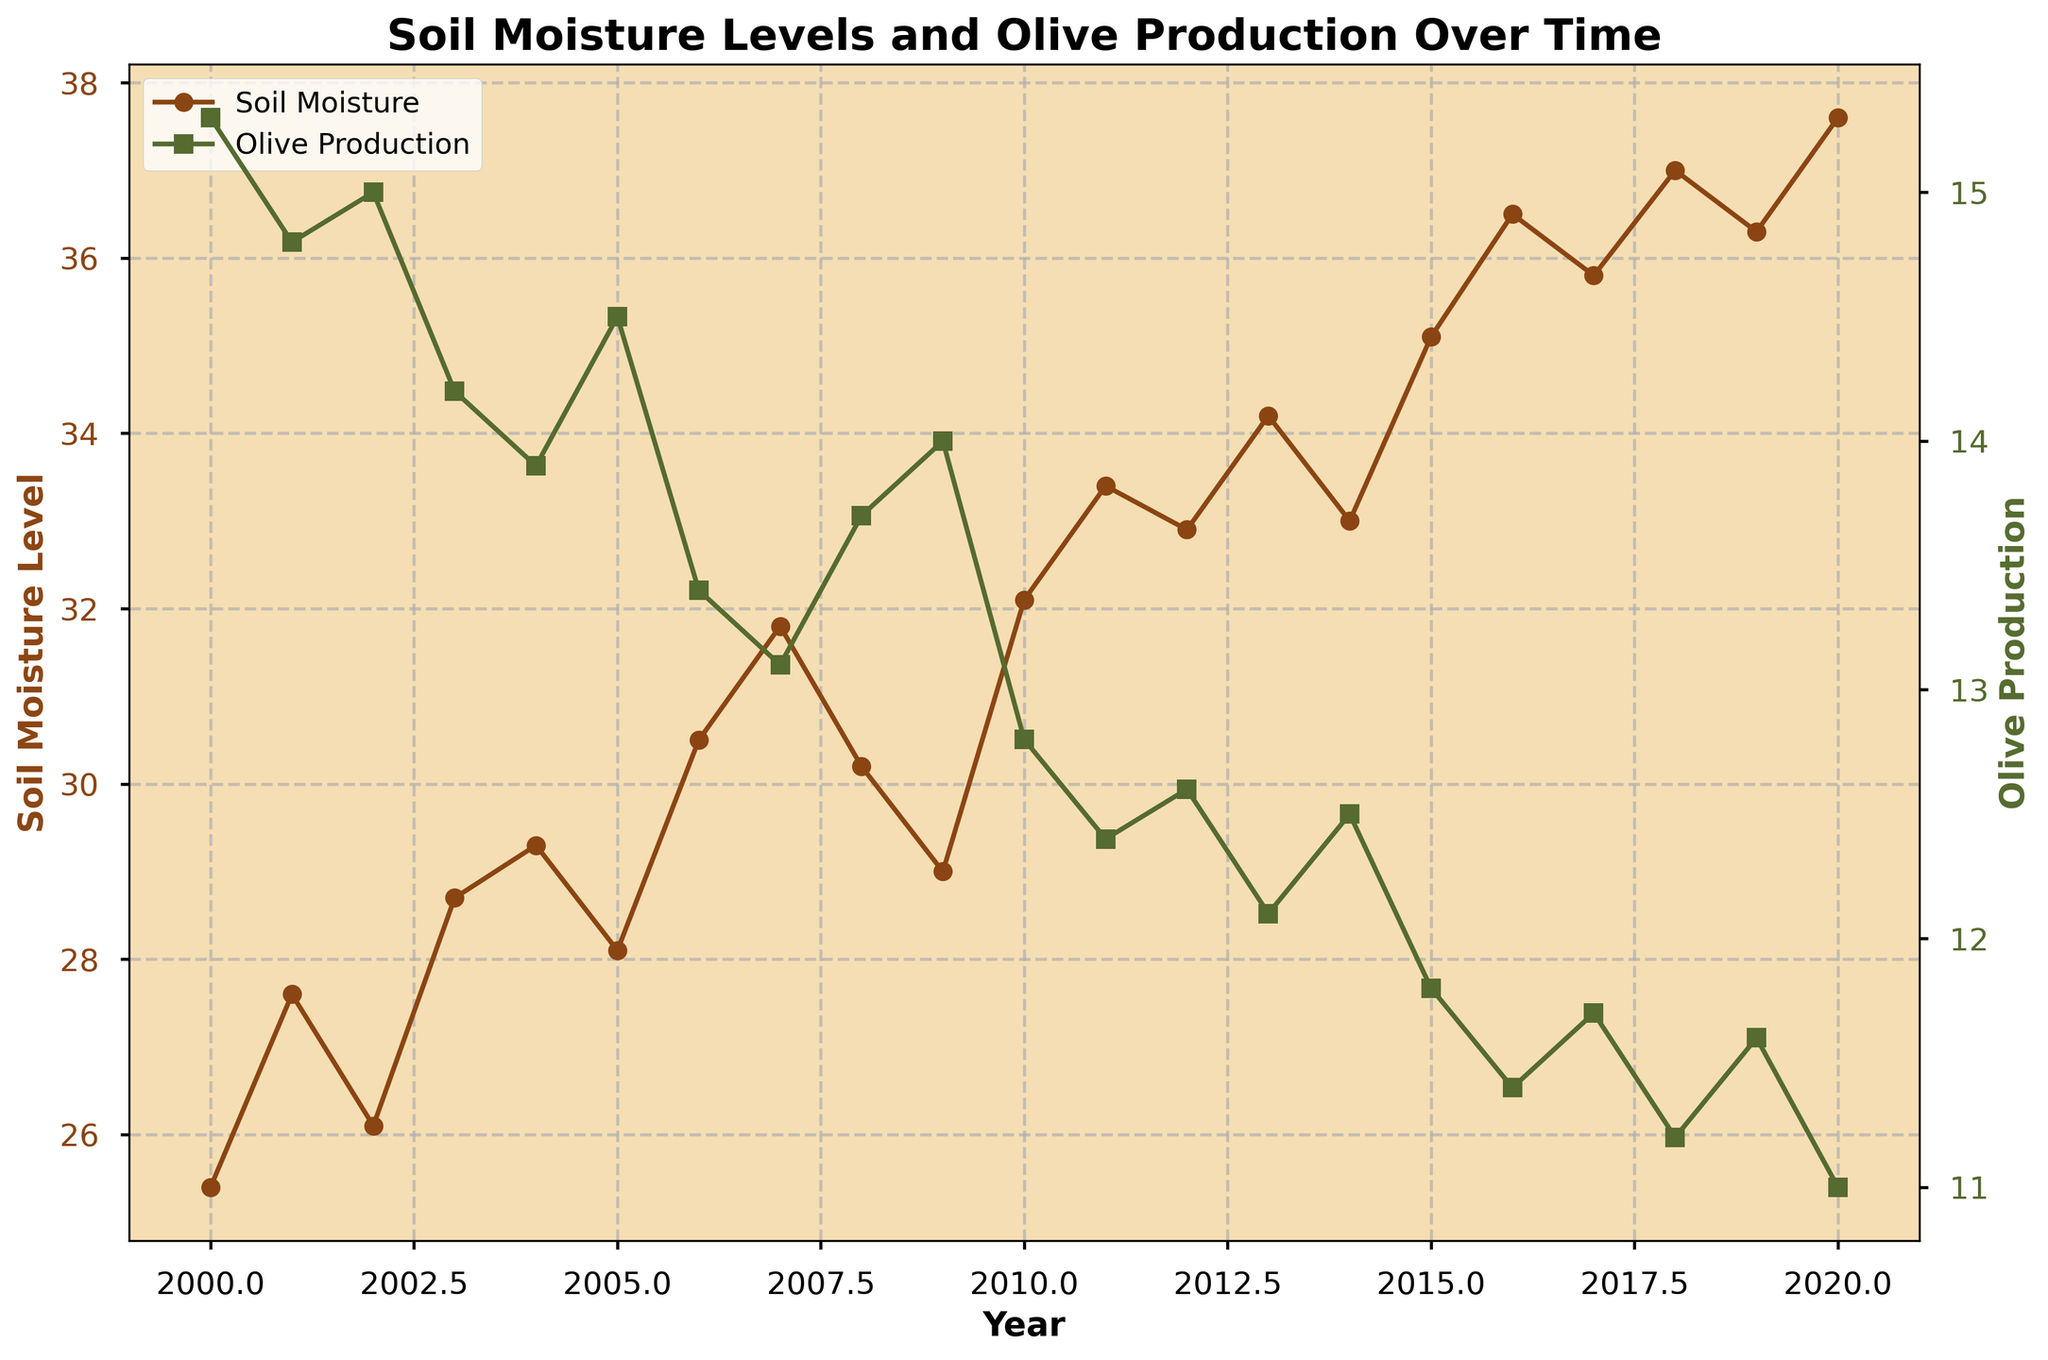What is the title of the plot? The title of the plot is typically located at the top center of a chart. In this case, it reads "Soil Moisture Levels and Olive Production Over Time."
Answer: "Soil Moisture Levels and Olive Production Over Time" Which year had the highest soil moisture level? To find the highest soil moisture level, scan the line representing soil moisture and identify the peak value. This occurs in 2020.
Answer: 2020 What trend do you observe between soil moisture levels and olive production from 2000 to 2020? Generally, as soil moisture levels increase over the years, olive production tends to decrease, indicating an inverse correlation.
Answer: Inverse correlation What is the olive production value for the year 2015? Locate the year 2015 on the X-axis and follow it up to meet the line representing olive production. The corresponding value on the Y-axis is approximately 11.8.
Answer: 11.8 By how much did soil moisture change from 2010 to 2020? Note the soil moisture levels in 2010 and 2020 (32.1 and 37.6 respectively). Subtract 32.1 from 37.6 to find the change.
Answer: 5.5 Which year shows the largest drop in olive production compared to its previous year? Examine the olive production values year by year. The year 2010 compared to 2009 shows a drop from 14.0 to 12.8, a decrease of 1.2 units, the largest observed.
Answer: 2010 Is there any year where olive production increased even though the soil moisture level also increased? Identify years where both olive production and soil moisture increased. In 2009, soil moisture decreased from 30.2 to 29.0, and olive production increased from 13.7 to 14.0.
Answer: No What is the average soil moisture level from 2000 to 2020? Sum all soil moisture values and divide by the number of years (21). The calculation is (25.4 + 27.6 + 26.1 + 28.7 + 29.3 + 28.1 + 30.5 + 31.8 + 30.2 + 29.0 + 32.1 + 33.4 + 32.9 + 34.2 + 33.0 + 35.1 + 36.5 + 35.8 + 37.0 + 36.3 + 37.6) / 21 = 31.7.
Answer: 31.7 Between 2018 and 2020, how consistent were the soil moisture levels? Between 2018 and 2020, the soil moisture values are 37.0, 36.3, and 37.6. These values do not deviate much, showing a consistent high level over these years.
Answer: Consistent Which year had a higher soil moisture level with lower olive production than in 2005? Identify years with soil moisture higher than 28.1 and olive production lower than 14.5. 2006 qualifies with soil moisture of 30.5 and olive production of 13.4.
Answer: 2006 